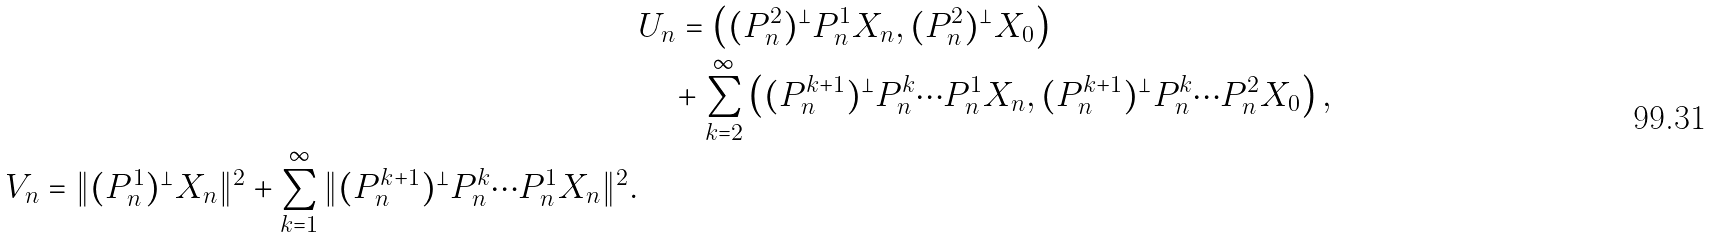Convert formula to latex. <formula><loc_0><loc_0><loc_500><loc_500>& U _ { n } = \left ( ( P _ { n } ^ { 2 } ) ^ { \bot } P _ { n } ^ { 1 } X _ { n } , ( P _ { n } ^ { 2 } ) ^ { \bot } X _ { 0 } \right ) \\ & \quad + \sum _ { k = 2 } ^ { \infty } \left ( ( P _ { n } ^ { k + 1 } ) ^ { \bot } P _ { n } ^ { k } \cdots P _ { n } ^ { 1 } X _ { n } , ( P _ { n } ^ { k + 1 } ) ^ { \bot } P _ { n } ^ { k } \cdots P _ { n } ^ { 2 } X _ { 0 } \right ) , \\ V _ { n } = \| ( P _ { n } ^ { 1 } ) ^ { \bot } X _ { n } \| ^ { 2 } + \sum _ { k = 1 } ^ { \infty } \| ( P _ { n } ^ { k + 1 } ) ^ { \bot } P _ { n } ^ { k } \cdots P _ { n } ^ { 1 } X _ { n } \| ^ { 2 } .</formula> 